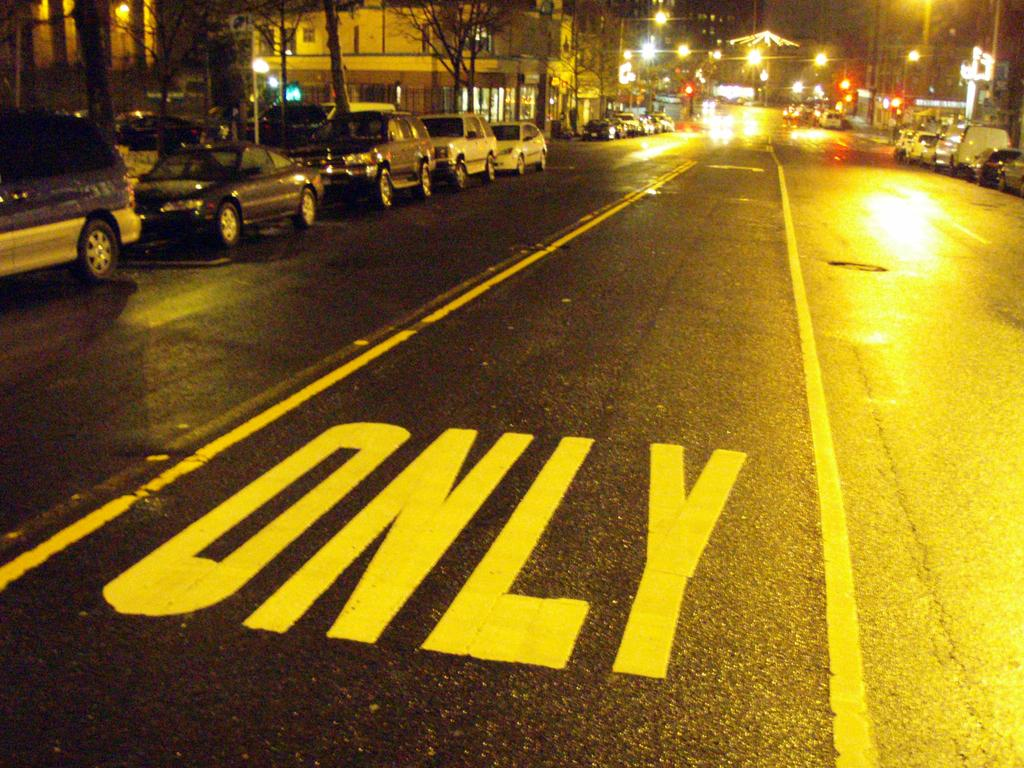<image>
Give a short and clear explanation of the subsequent image. The lane marked on the pavement is a turn only lane. 